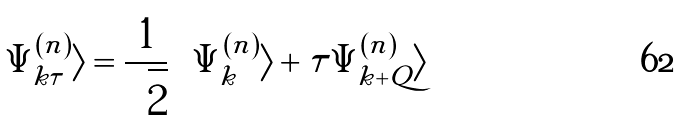Convert formula to latex. <formula><loc_0><loc_0><loc_500><loc_500>| \Psi _ { { k } \tau } ^ { ( n ) } \rangle = \frac { 1 } { \sqrt { 2 } } \left ( | \Psi _ { k } ^ { ( n ) } \rangle + \tau | \Psi _ { { k } + { Q } } ^ { ( n ) } \rangle \right )</formula> 